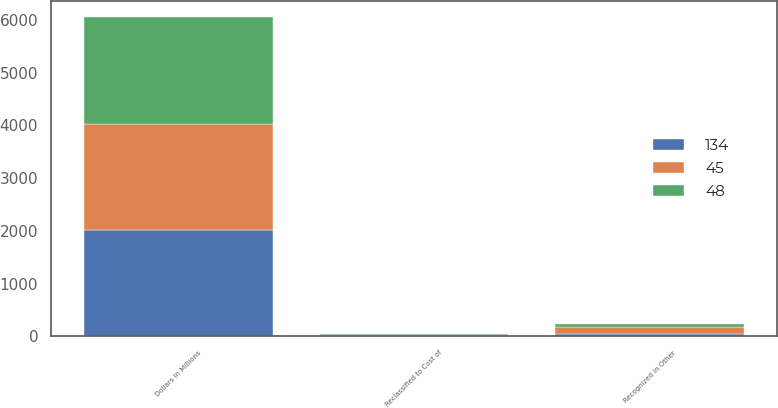<chart> <loc_0><loc_0><loc_500><loc_500><stacked_bar_chart><ecel><fcel>Dollars in Millions<fcel>Recognized in Other<fcel>Reclassified to Cost of<nl><fcel>48<fcel>2018<fcel>45<fcel>4<nl><fcel>45<fcel>2017<fcel>134<fcel>12<nl><fcel>134<fcel>2016<fcel>48<fcel>20<nl></chart> 